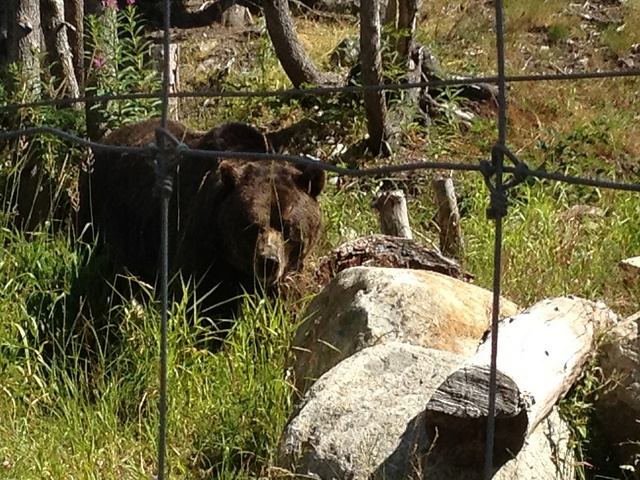Describe the objects in this image and their specific colors. I can see a bear in black, gray, and maroon tones in this image. 